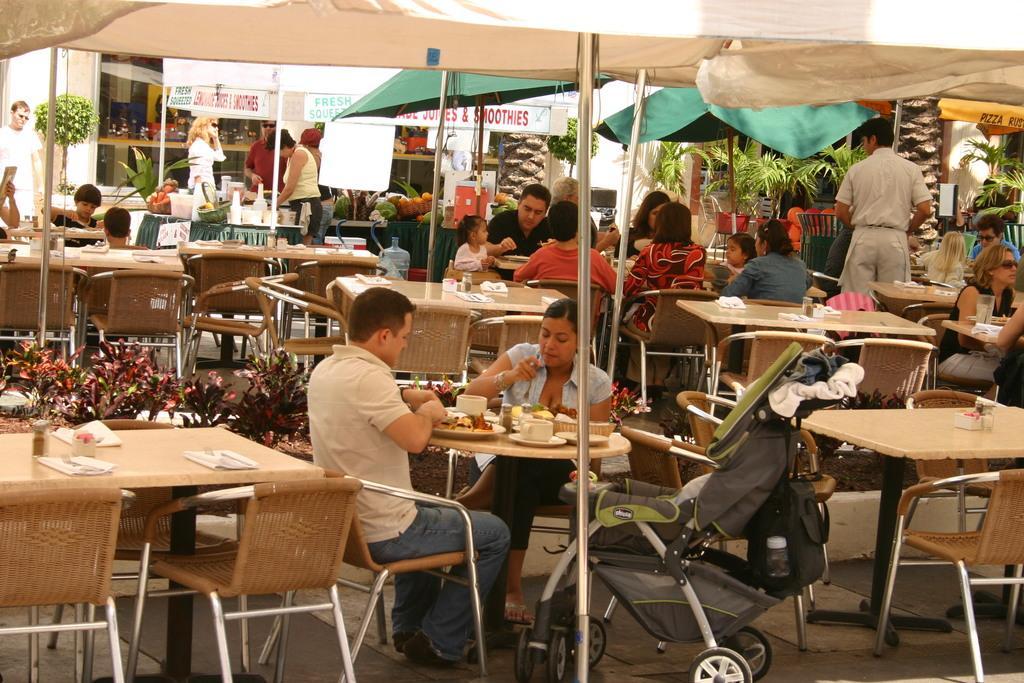In one or two sentences, can you explain what this image depicts? It looks like a food court hear a man is sitting on the chair and eating food and a woman is doing the same. If you observe the right side of an image there are plants and umbrella. If you look at the middle of an image coming left side of an image there is a man standing at here. 